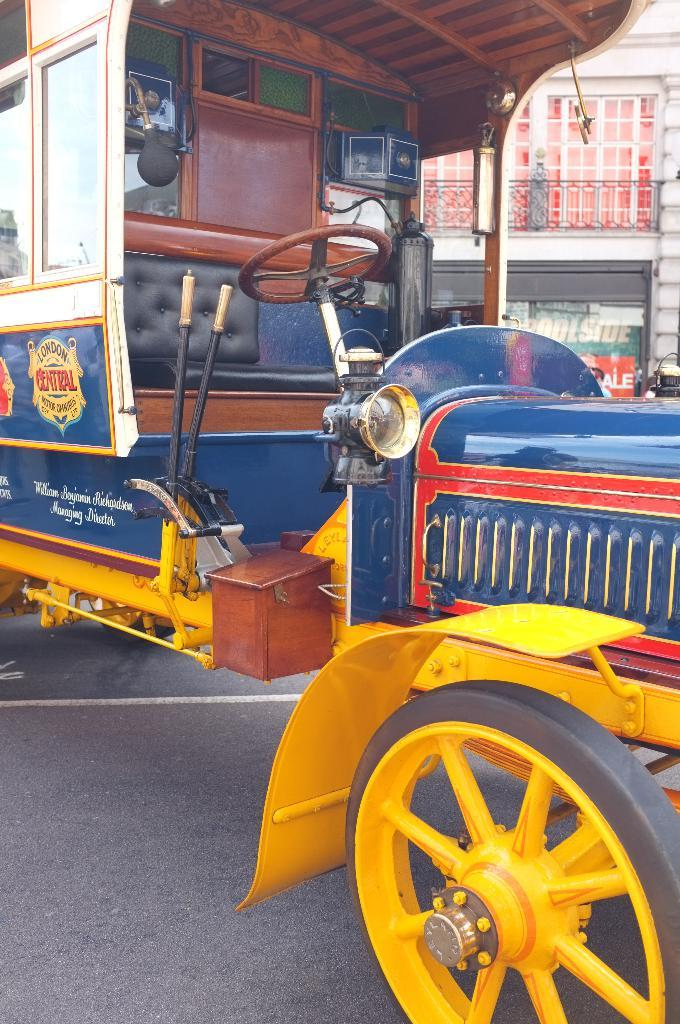What is the main subject of the image? The main subject of the image is a vehicle. Where is the vehicle located in the image? The vehicle is on a road. What can be seen in the background of the image? There is a building in the background of the image. What type of parenting advice can be seen in the image? There is no parenting advice present in the image; it features a vehicle on a road with a building in the background. What type of cabbage is growing in the image? There is no cabbage present in the image. 